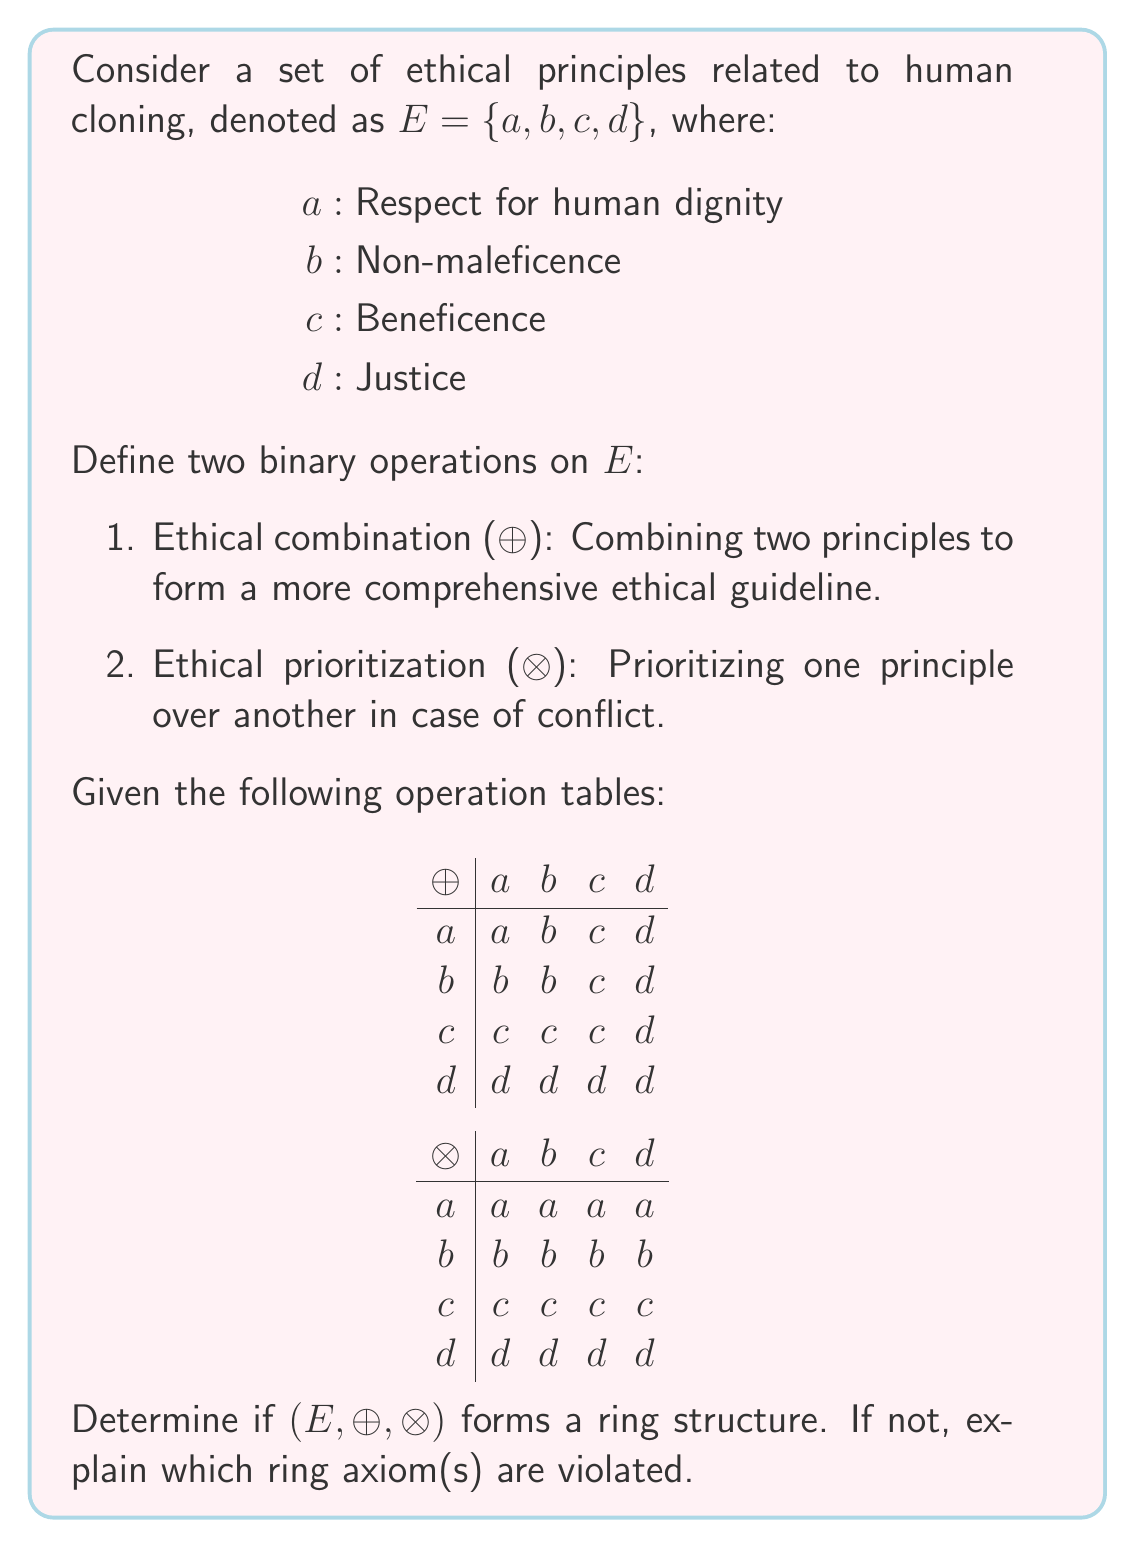Solve this math problem. To determine if $(E, \oplus, \otimes)$ forms a ring structure, we need to check if it satisfies all the ring axioms:

1. $(E, \oplus)$ is an abelian group:
   a) Closure: Satisfied, as all combinations result in elements of $E$.
   b) Associativity: $(a \oplus b) \oplus c = a \oplus (b \oplus c)$ for all $a, b, c \in E$. This holds.
   c) Commutativity: $a \oplus b = b \oplus a$ for all $a, b \in E$. This holds.
   d) Identity element: $d$ is the identity element, as $a \oplus d = d \oplus a = a$ for all $a \in E$.
   e) Inverse elements: Each element is its own inverse, as $a \oplus a = a$ for all $a \in E$.

2. $(E, \otimes)$ is a monoid:
   a) Closure: Satisfied, as all combinations result in elements of $E$.
   b) Associativity: $(a \otimes b) \otimes c = a \otimes (b \otimes c)$ for all $a, b, c \in E$. This holds.
   c) Identity element: $a$ is the identity element, as $a \otimes x = x \otimes a = x$ for all $x \in E$.

3. Distributivity:
   Left distributivity: $a \otimes (b \oplus c) = (a \otimes b) \oplus (a \otimes c)$
   Right distributivity: $(a \oplus b) \otimes c = (a \otimes c) \oplus (b \otimes c)$

Let's check the distributivity property:

Consider $a \otimes (b \oplus c)$:
$a \otimes (b \oplus c) = a \otimes c = c$

Now, $(a \otimes b) \oplus (a \otimes c)$:
$(a \otimes b) \oplus (a \otimes c) = b \oplus c = c$

This shows that left distributivity holds. Similarly, we can verify that right distributivity also holds.

However, there is a problem with the ring structure. In a ring, the multiplicative identity (for $\otimes$) should be different from the additive identity (for $\oplus$). In this case, we have $d$ as the additive identity and $a$ as the multiplicative identity, which satisfies this requirement.

The main issue is that $(E, \otimes)$ lacks multiplicative inverses for non-identity elements. In a ring, every non-zero element should have a multiplicative inverse. Here, $b$, $c$, and $d$ do not have multiplicative inverses.

Therefore, $(E, \oplus, \otimes)$ does not form a ring structure.
Answer: $(E, \oplus, \otimes)$ does not form a ring structure. The main axiom violated is the existence of multiplicative inverses for all non-zero elements under the $\otimes$ operation. Specifically, $b$, $c$, and $d$ do not have multiplicative inverses. 